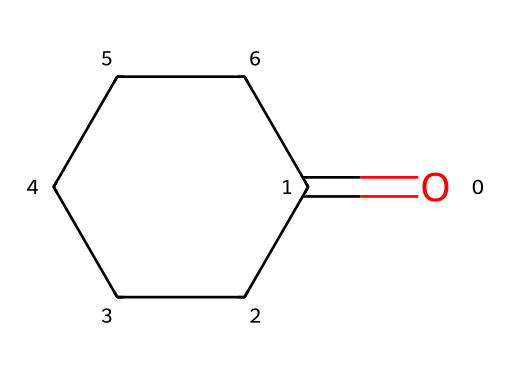What is the molecular formula of this ketone? To determine the molecular formula, count the number of each type of atom present in the structure. There are 6 carbon atoms and 10 hydrogen atoms, along with one oxygen atom. Thus, the molecular formula is C6H10O.
Answer: C6H10O How many carbon atoms are in cyclohexanone? By examining the structure, we can see that there are six carbon atoms (C) present in the ring structure of the chemical.
Answer: 6 What type of functional group is present in cyclohexanone? This chemical contains a carbonyl functional group (C=O) which is characteristic of ketones.
Answer: carbonyl Does cyclohexanone contain any double bonds? In the structure, there is one double bond present between the carbon and oxygen (C=O), which is the defining feature of the carbonyl group in ketones, but there are no C=C bonds.
Answer: yes What is the physical state of cyclohexanone at room temperature? Given that cyclohexanone is a ketone with a low boiling point, it is typically a liquid at room temperature.
Answer: liquid Is cyclohexanone a polar or non-polar compound? The presence of the carbonyl group creates a polar region in the molecule, making cyclohexanone a polar compound overall due to the difference in electronegativity between carbon and oxygen.
Answer: polar What is the primary use of cyclohexanone in sports equipment? Cyclohexanone is commonly used as a solvent and a precursor in the production of some adhesives that are used in various types of sports gear and equipment.
Answer: adhesives 